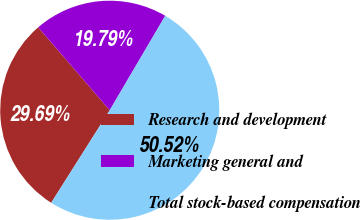<chart> <loc_0><loc_0><loc_500><loc_500><pie_chart><fcel>Research and development<fcel>Marketing general and<fcel>Total stock-based compensation<nl><fcel>29.69%<fcel>19.79%<fcel>50.52%<nl></chart> 